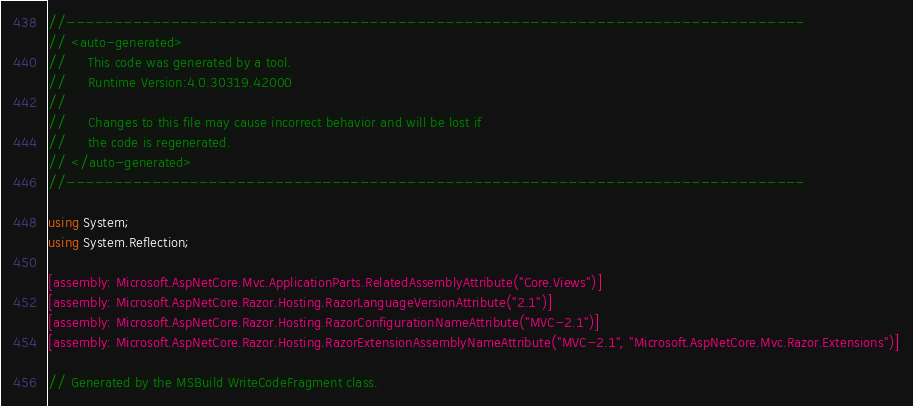Convert code to text. <code><loc_0><loc_0><loc_500><loc_500><_C#_>//------------------------------------------------------------------------------
// <auto-generated>
//     This code was generated by a tool.
//     Runtime Version:4.0.30319.42000
//
//     Changes to this file may cause incorrect behavior and will be lost if
//     the code is regenerated.
// </auto-generated>
//------------------------------------------------------------------------------

using System;
using System.Reflection;

[assembly: Microsoft.AspNetCore.Mvc.ApplicationParts.RelatedAssemblyAttribute("Core.Views")]
[assembly: Microsoft.AspNetCore.Razor.Hosting.RazorLanguageVersionAttribute("2.1")]
[assembly: Microsoft.AspNetCore.Razor.Hosting.RazorConfigurationNameAttribute("MVC-2.1")]
[assembly: Microsoft.AspNetCore.Razor.Hosting.RazorExtensionAssemblyNameAttribute("MVC-2.1", "Microsoft.AspNetCore.Mvc.Razor.Extensions")]

// Generated by the MSBuild WriteCodeFragment class.

</code> 